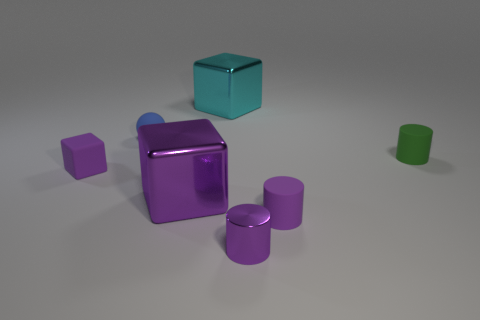What shape is the tiny object that is both on the right side of the tiny shiny cylinder and behind the big purple cube?
Your answer should be very brief. Cylinder. There is a large cyan cube; are there any objects in front of it?
Your response must be concise. Yes. There is a cyan metal thing that is the same shape as the large purple object; what size is it?
Provide a succinct answer. Large. Is the shape of the small purple metallic thing the same as the tiny green object?
Your response must be concise. Yes. There is a metal block behind the large metallic thing that is in front of the green cylinder; what size is it?
Your response must be concise. Large. What is the color of the other tiny shiny object that is the same shape as the small green thing?
Ensure brevity in your answer.  Purple. How many cylinders have the same color as the tiny shiny thing?
Provide a short and direct response. 1. What size is the cyan object?
Give a very brief answer. Large. Is the cyan thing the same size as the purple metallic cube?
Ensure brevity in your answer.  Yes. What is the color of the block that is both right of the tiny blue matte ball and in front of the cyan object?
Your answer should be very brief. Purple. 